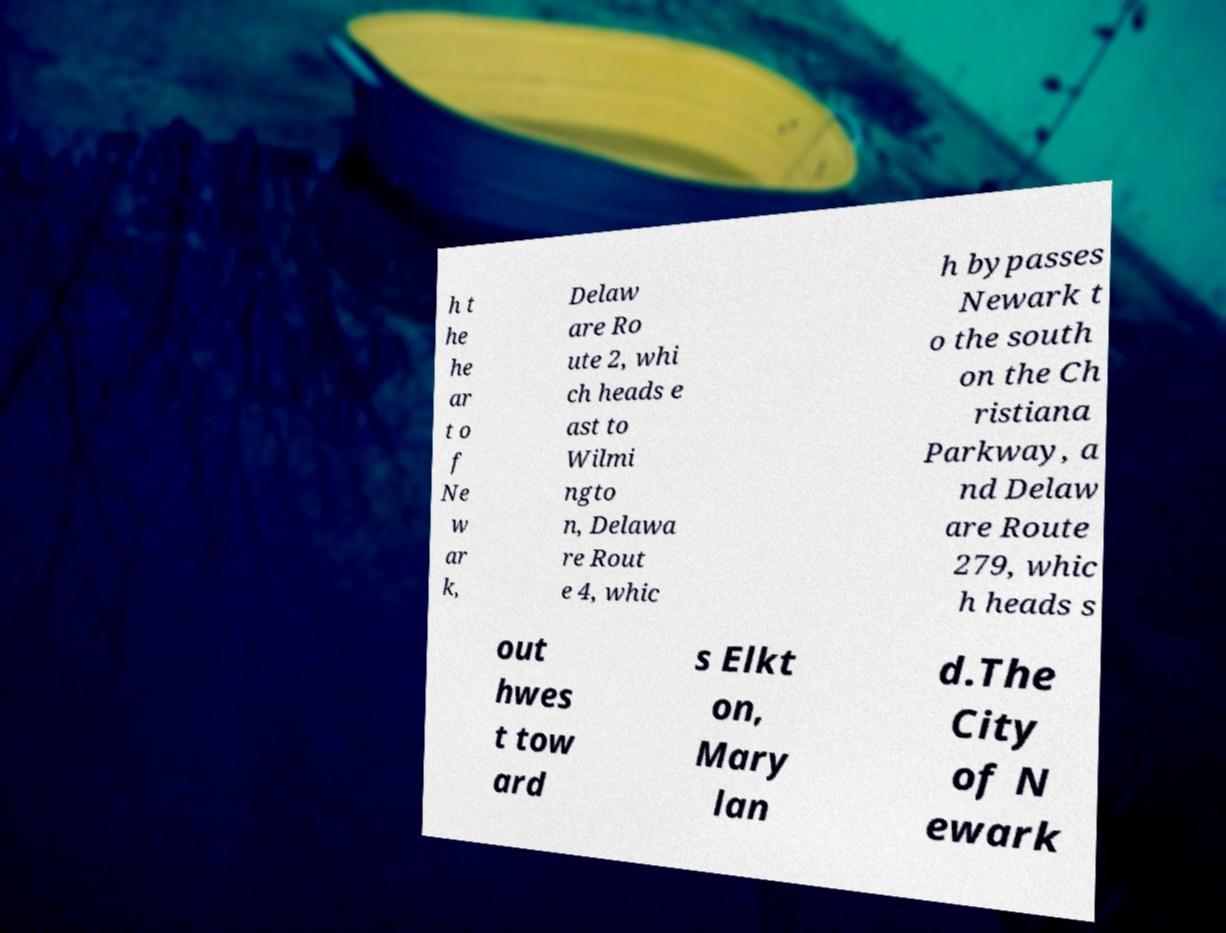For documentation purposes, I need the text within this image transcribed. Could you provide that? h t he he ar t o f Ne w ar k, Delaw are Ro ute 2, whi ch heads e ast to Wilmi ngto n, Delawa re Rout e 4, whic h bypasses Newark t o the south on the Ch ristiana Parkway, a nd Delaw are Route 279, whic h heads s out hwes t tow ard s Elkt on, Mary lan d.The City of N ewark 